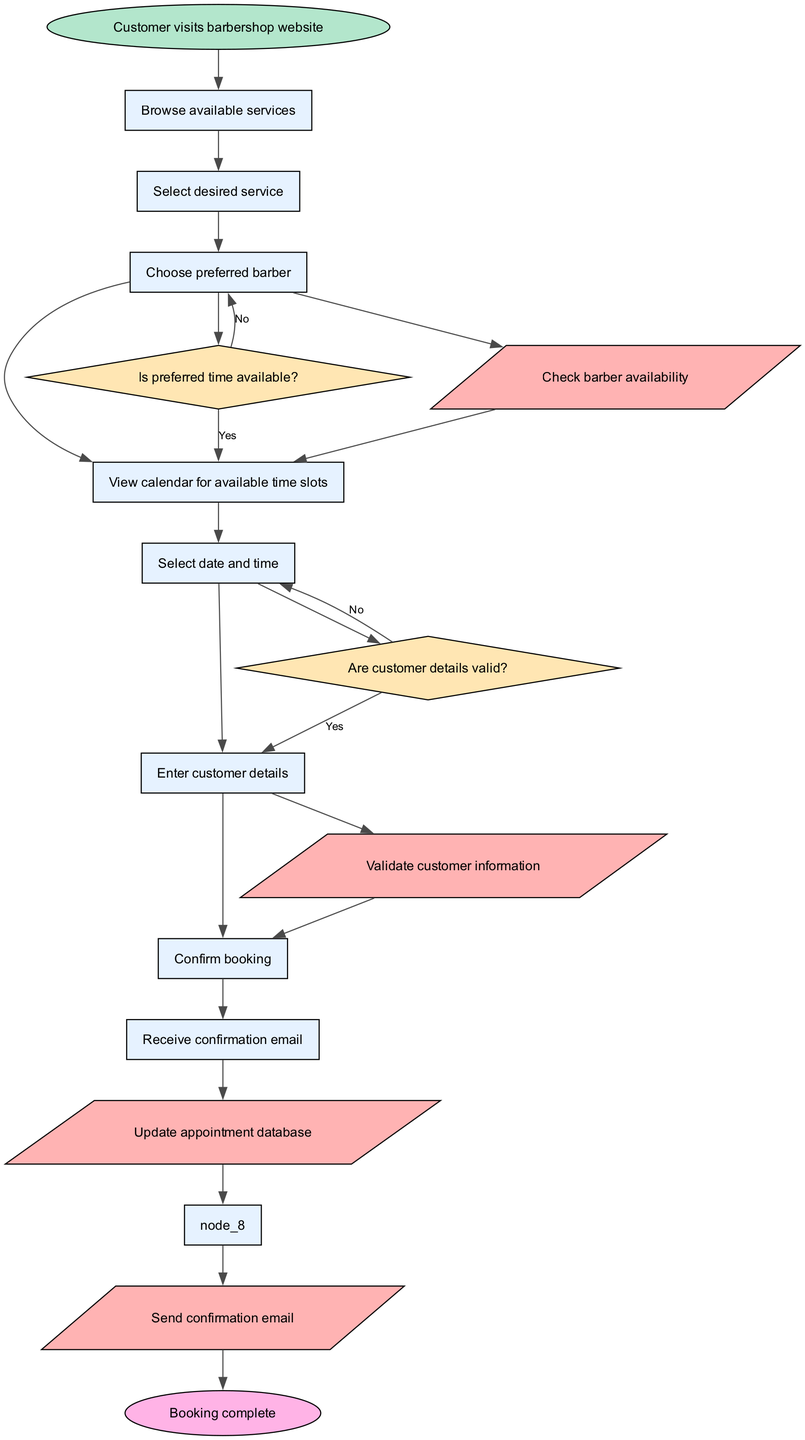What is the starting point of the flowchart? The starting point of the flowchart is defined as the event when the customer visits the barbershop website. This is the first node in the diagram, leading to the subsequent actions.
Answer: Customer visits barbershop website How many nodes are there in total? The diagram consists of several types of nodes: the start node, eight process nodes, two decision nodes, and the end node. Adding them together, there are a total of twelve nodes in the flowchart.
Answer: Twelve What service is selected after browsing? In the flowchart, after browsing available services, the customer selects the desired service. This message flows directly from the browsing step to the selection.
Answer: Select desired service What is the first decision point in the flowchart? The first decision point is labeled "Is preferred time available?" This decision comes after the customer views the calendar for available time slots.
Answer: Is preferred time available? How does the flow progress if customer details are invalid? If the customer details are invalid at the second decision point (Are customer details valid?), the flowchart indicates a "No" path that loops back to the "Enter customer details" step. Therefore, the customer must re-enter their information before proceeding to confirm the booking.
Answer: Loop back to Enter customer details Which process updates the appointment database? The process that updates the appointment database is labeled "Update appointment database" in the flowchart. It follows the confirmation of valid customer details and is connected to the confirmation email sending.
Answer: Update appointment database What node follows the selected date and time? After the selected date and time, the customer is prompted to enter customer details. This is the logical next step as the system needs necessary information for booking.
Answer: Enter customer details What happens after the appointment confirmation? After the appointment confirmation, the customer receives a confirmation email. This completes the booking process and provides the customer with necessary details about their appointment.
Answer: Receive confirmation email How many decision points are in the flowchart? There are two decision points in the flowchart that are necessary for determining the flow based on availability and validity of customer information. These decision nodes facilitate choices in the process.
Answer: Two 